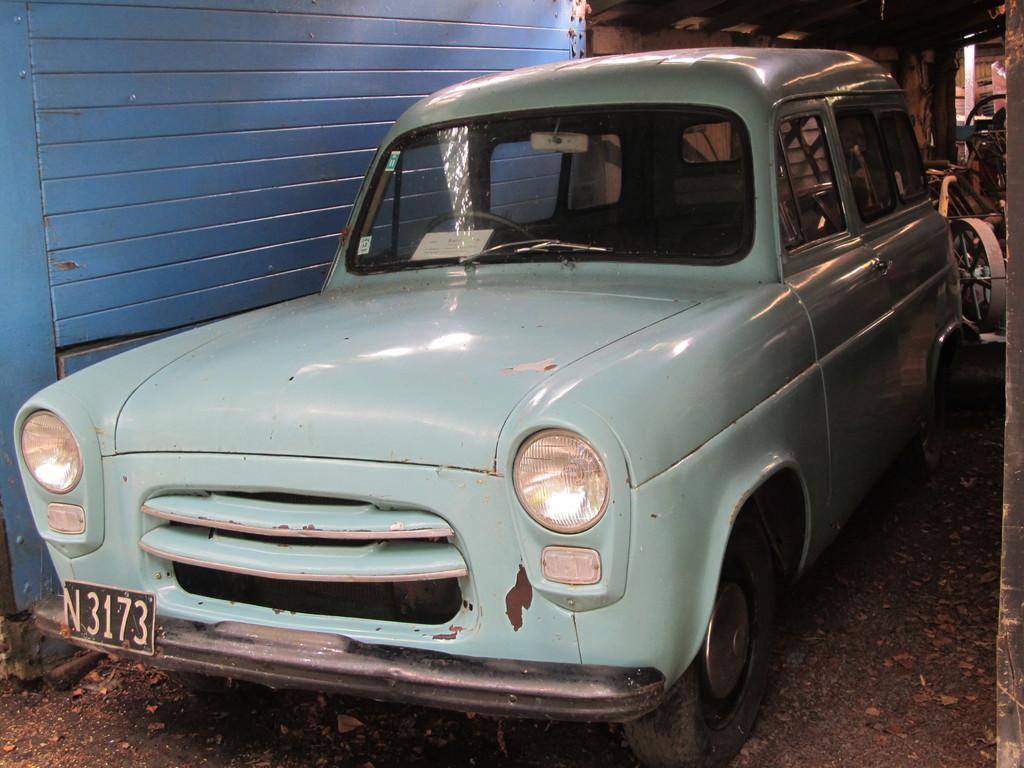Can you describe this image briefly? In this picture, there is a car facing towards the left. It is in light blue in color. 